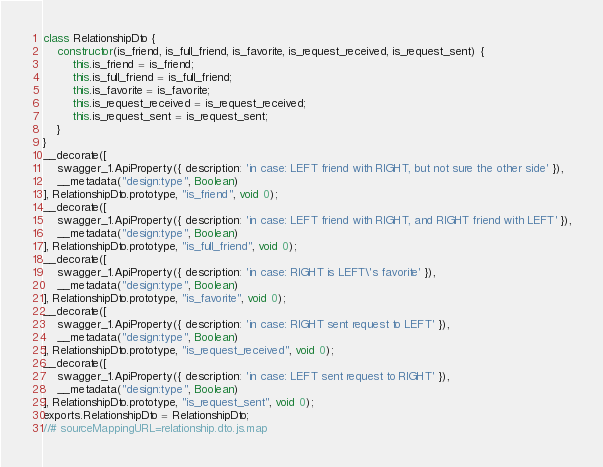<code> <loc_0><loc_0><loc_500><loc_500><_JavaScript_>class RelationshipDto {
    constructor(is_friend, is_full_friend, is_favorite, is_request_received, is_request_sent) {
        this.is_friend = is_friend;
        this.is_full_friend = is_full_friend;
        this.is_favorite = is_favorite;
        this.is_request_received = is_request_received;
        this.is_request_sent = is_request_sent;
    }
}
__decorate([
    swagger_1.ApiProperty({ description: 'in case: LEFT friend with RIGHT, but not sure the other side' }),
    __metadata("design:type", Boolean)
], RelationshipDto.prototype, "is_friend", void 0);
__decorate([
    swagger_1.ApiProperty({ description: 'in case: LEFT friend with RIGHT, and RIGHT friend with LEFT' }),
    __metadata("design:type", Boolean)
], RelationshipDto.prototype, "is_full_friend", void 0);
__decorate([
    swagger_1.ApiProperty({ description: 'in case: RIGHT is LEFT\'s favorite' }),
    __metadata("design:type", Boolean)
], RelationshipDto.prototype, "is_favorite", void 0);
__decorate([
    swagger_1.ApiProperty({ description: 'in case: RIGHT sent request to LEFT' }),
    __metadata("design:type", Boolean)
], RelationshipDto.prototype, "is_request_received", void 0);
__decorate([
    swagger_1.ApiProperty({ description: 'in case: LEFT sent request to RIGHT' }),
    __metadata("design:type", Boolean)
], RelationshipDto.prototype, "is_request_sent", void 0);
exports.RelationshipDto = RelationshipDto;
//# sourceMappingURL=relationship.dto.js.map</code> 